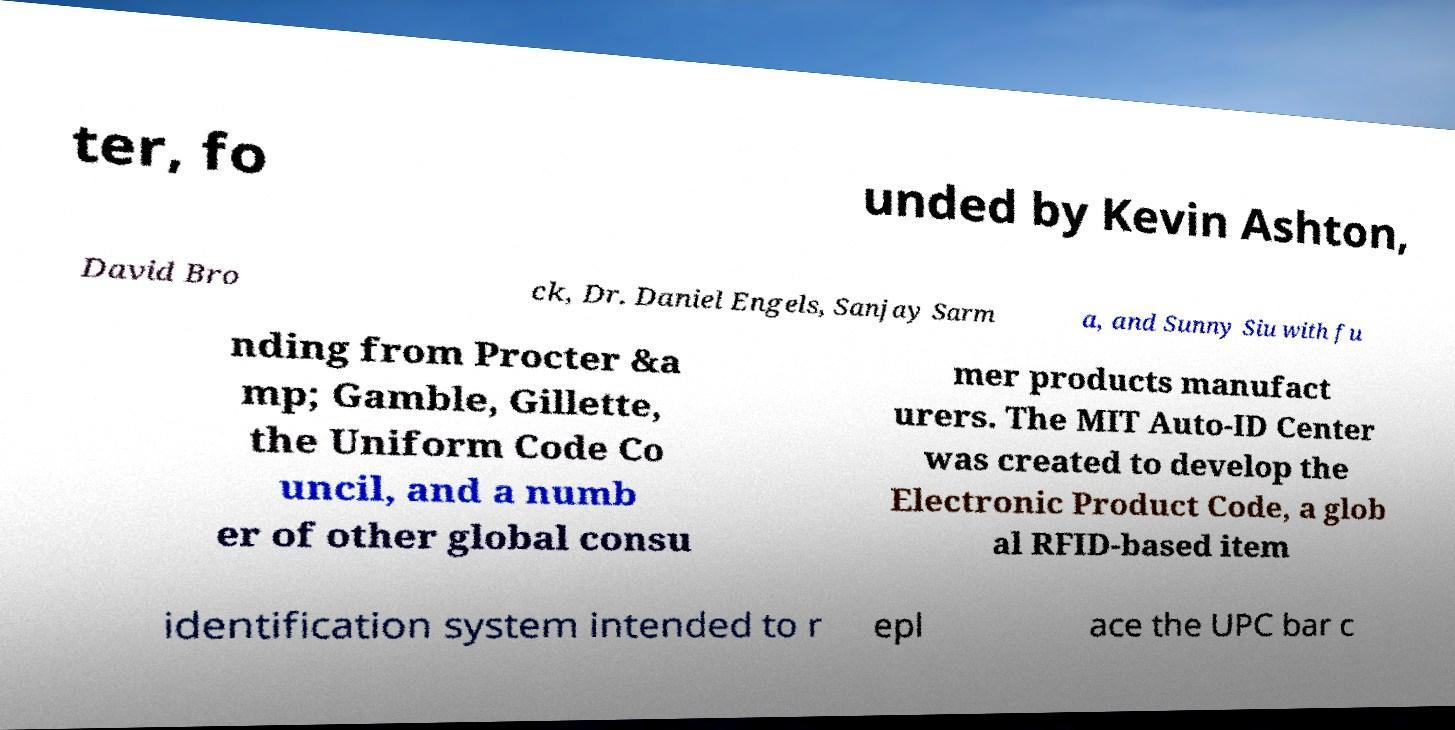Could you assist in decoding the text presented in this image and type it out clearly? ter, fo unded by Kevin Ashton, David Bro ck, Dr. Daniel Engels, Sanjay Sarm a, and Sunny Siu with fu nding from Procter &a mp; Gamble, Gillette, the Uniform Code Co uncil, and a numb er of other global consu mer products manufact urers. The MIT Auto-ID Center was created to develop the Electronic Product Code, a glob al RFID-based item identification system intended to r epl ace the UPC bar c 